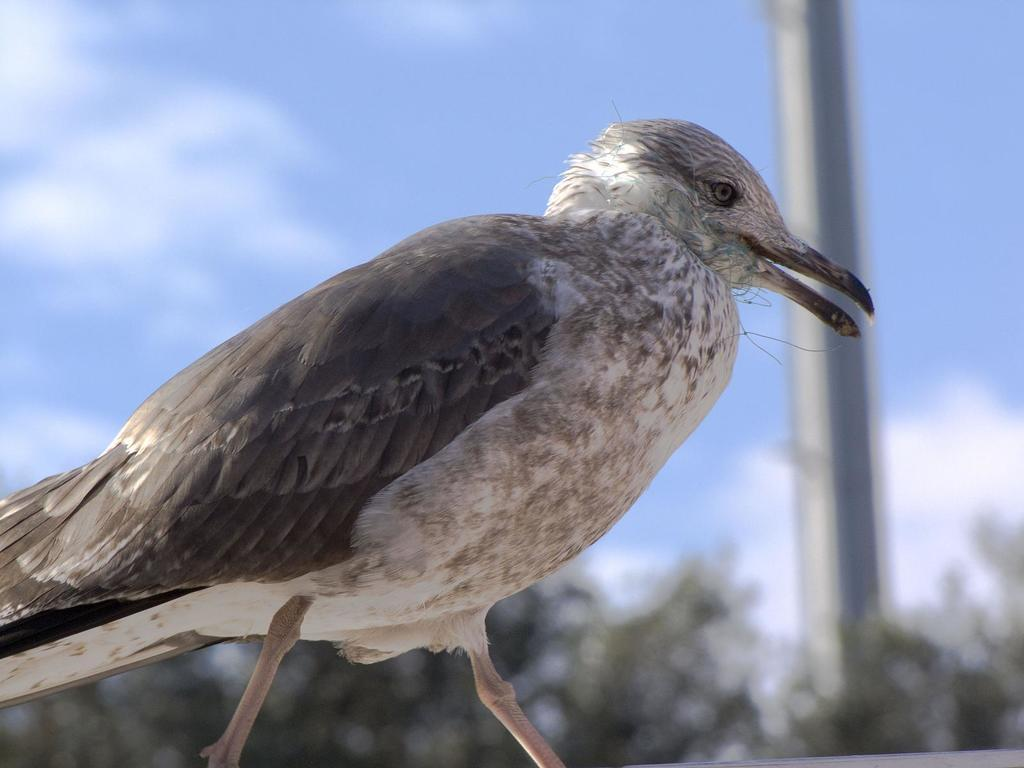What type of animal can be seen in the image? There is a bird in the image. What is located in the background of the image? There is a pole and trees in the background of the image. What is the condition of the sky in the image? The sky is clear in the image. What type of muscle is visible on the bird in the image? There is no specific muscle visible on the bird in the image. Is the queen present in the image? There is no queen depicted in the image; it features a bird and background elements. 